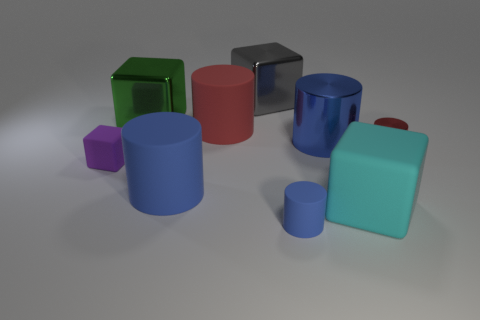How many blue cylinders must be subtracted to get 1 blue cylinders? 2 Subtract all gray blocks. How many blue cylinders are left? 3 Subtract 1 cylinders. How many cylinders are left? 4 Subtract all red matte cylinders. How many cylinders are left? 4 Subtract all cyan cubes. How many cubes are left? 3 Subtract all cylinders. How many objects are left? 4 Subtract all brown cylinders. Subtract all brown cubes. How many cylinders are left? 5 Subtract 0 brown balls. How many objects are left? 9 Subtract all small rubber cylinders. Subtract all big cyan cubes. How many objects are left? 7 Add 4 blue things. How many blue things are left? 7 